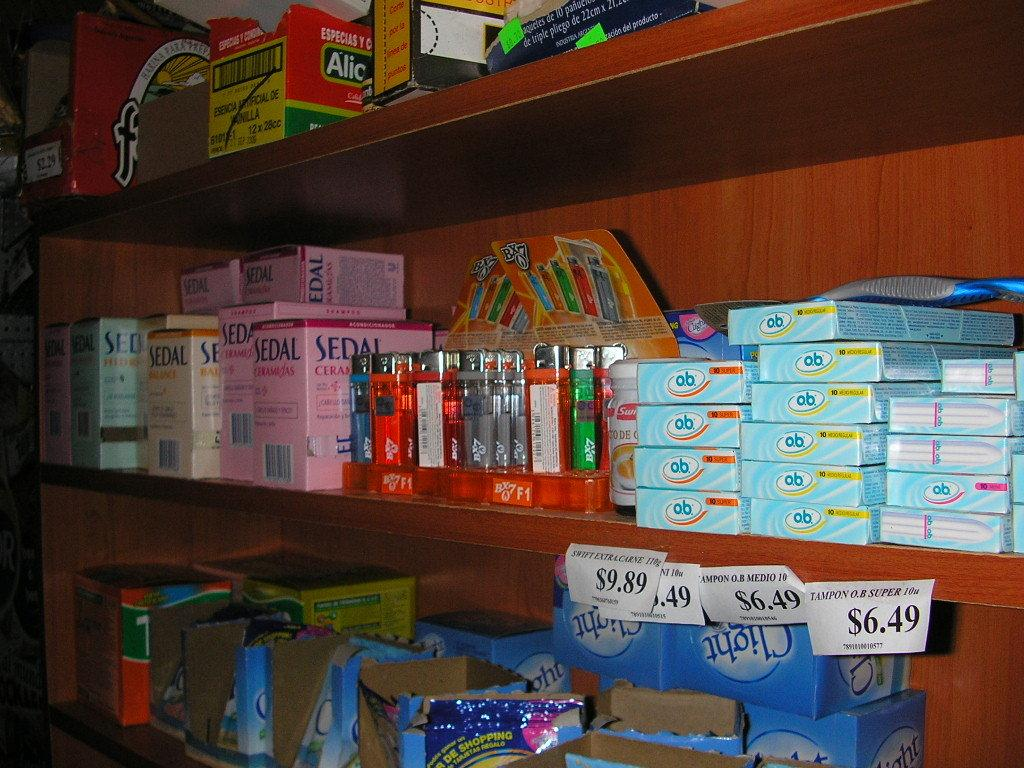<image>
Describe the image concisely. Store shelf that shows objects on sale including a pink box of SEDAL. 